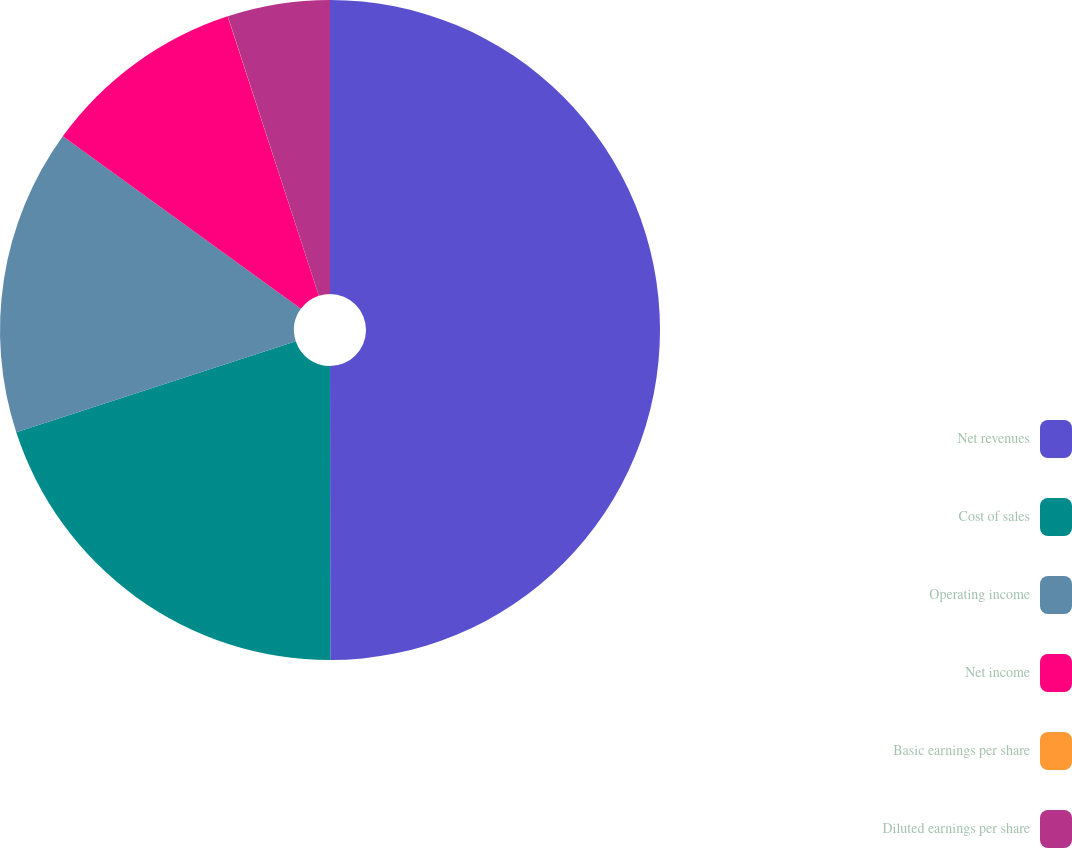Convert chart to OTSL. <chart><loc_0><loc_0><loc_500><loc_500><pie_chart><fcel>Net revenues<fcel>Cost of sales<fcel>Operating income<fcel>Net income<fcel>Basic earnings per share<fcel>Diluted earnings per share<nl><fcel>49.99%<fcel>20.0%<fcel>15.0%<fcel>10.0%<fcel>0.01%<fcel>5.01%<nl></chart> 